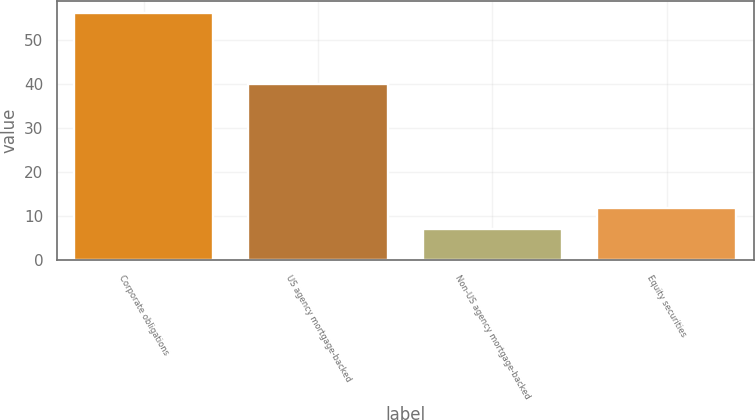Convert chart. <chart><loc_0><loc_0><loc_500><loc_500><bar_chart><fcel>Corporate obligations<fcel>US agency mortgage-backed<fcel>Non-US agency mortgage-backed<fcel>Equity securities<nl><fcel>56<fcel>40<fcel>7<fcel>11.9<nl></chart> 